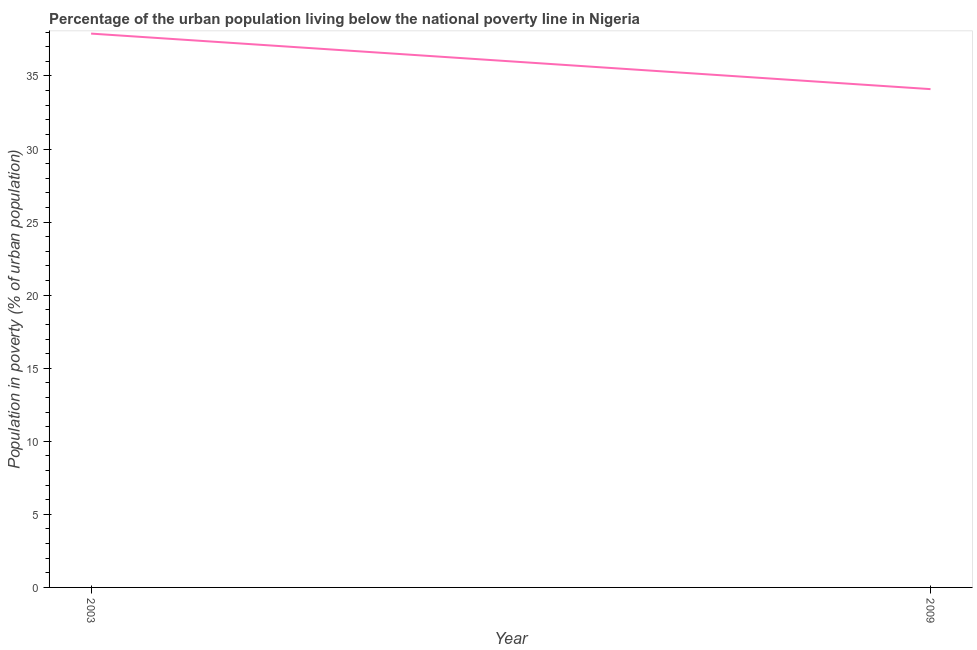What is the percentage of urban population living below poverty line in 2009?
Your answer should be compact. 34.1. Across all years, what is the maximum percentage of urban population living below poverty line?
Your answer should be very brief. 37.9. Across all years, what is the minimum percentage of urban population living below poverty line?
Ensure brevity in your answer.  34.1. What is the difference between the percentage of urban population living below poverty line in 2003 and 2009?
Keep it short and to the point. 3.8. What is the average percentage of urban population living below poverty line per year?
Offer a very short reply. 36. Do a majority of the years between 2009 and 2003 (inclusive) have percentage of urban population living below poverty line greater than 9 %?
Your answer should be compact. No. What is the ratio of the percentage of urban population living below poverty line in 2003 to that in 2009?
Offer a very short reply. 1.11. Is the percentage of urban population living below poverty line in 2003 less than that in 2009?
Provide a succinct answer. No. How many lines are there?
Offer a very short reply. 1. How many years are there in the graph?
Provide a short and direct response. 2. What is the difference between two consecutive major ticks on the Y-axis?
Keep it short and to the point. 5. Are the values on the major ticks of Y-axis written in scientific E-notation?
Your response must be concise. No. Does the graph contain grids?
Keep it short and to the point. No. What is the title of the graph?
Offer a very short reply. Percentage of the urban population living below the national poverty line in Nigeria. What is the label or title of the Y-axis?
Your answer should be compact. Population in poverty (% of urban population). What is the Population in poverty (% of urban population) of 2003?
Make the answer very short. 37.9. What is the Population in poverty (% of urban population) in 2009?
Make the answer very short. 34.1. What is the ratio of the Population in poverty (% of urban population) in 2003 to that in 2009?
Your answer should be compact. 1.11. 